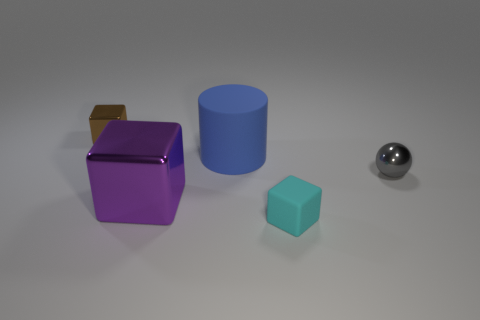Subtract all tiny blocks. How many blocks are left? 1 Add 2 purple matte things. How many objects exist? 7 Subtract all blocks. How many objects are left? 2 Subtract all large shiny objects. Subtract all gray metallic spheres. How many objects are left? 3 Add 3 blue objects. How many blue objects are left? 4 Add 1 small red matte things. How many small red matte things exist? 1 Subtract 0 purple cylinders. How many objects are left? 5 